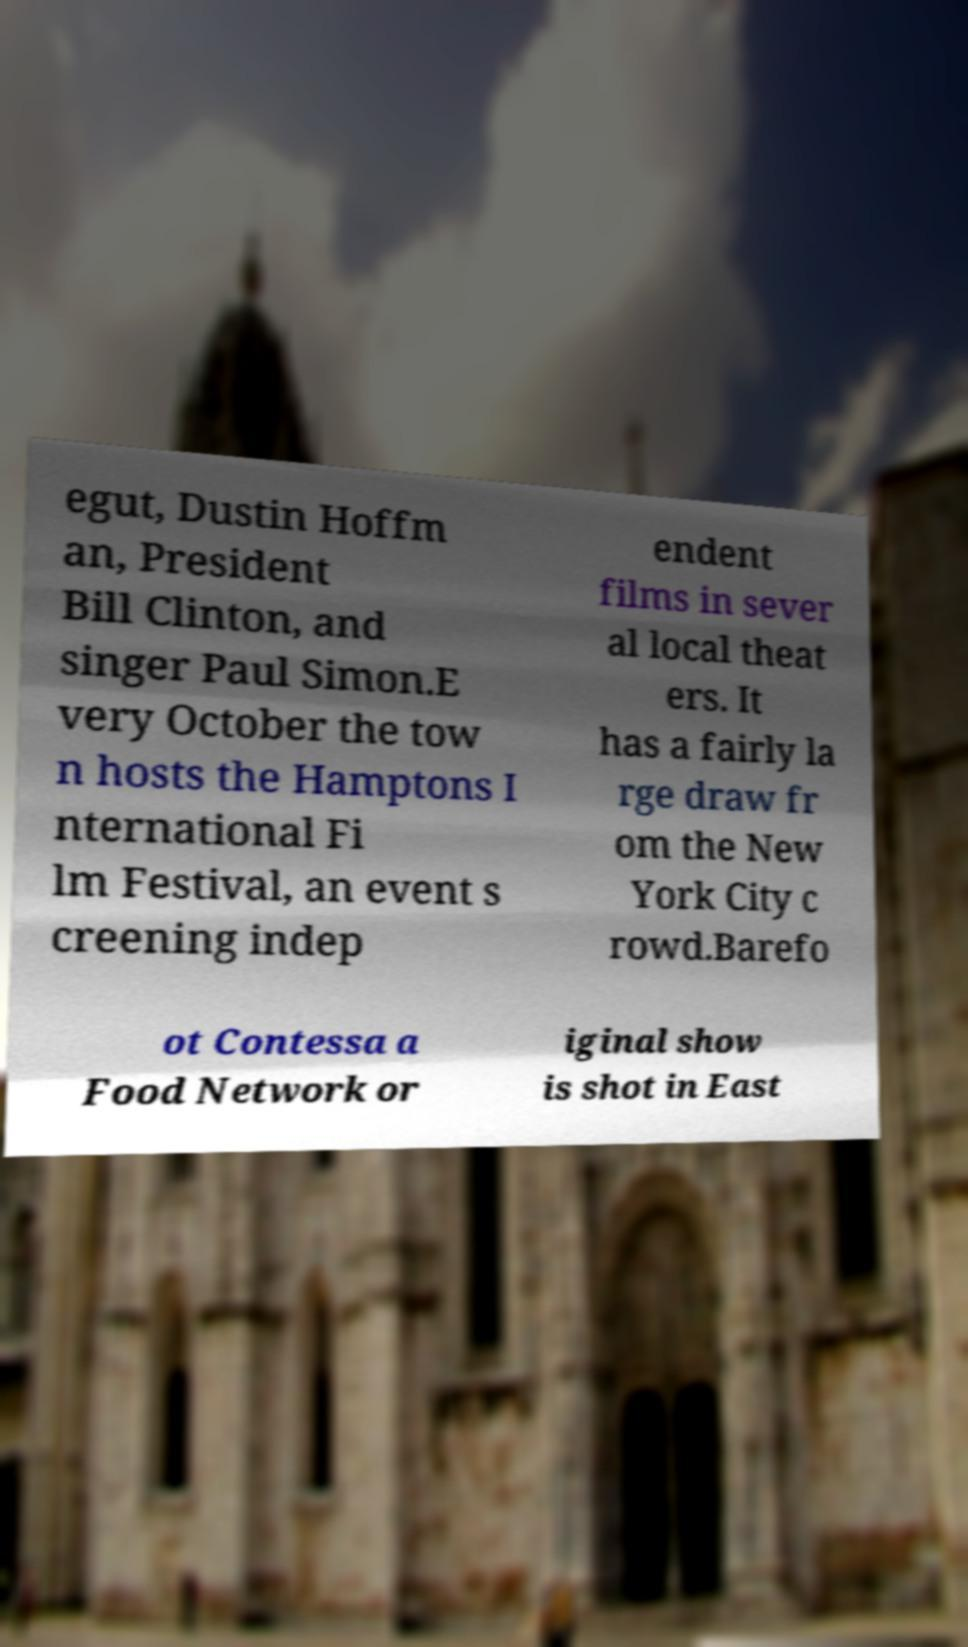What messages or text are displayed in this image? I need them in a readable, typed format. egut, Dustin Hoffm an, President Bill Clinton, and singer Paul Simon.E very October the tow n hosts the Hamptons I nternational Fi lm Festival, an event s creening indep endent films in sever al local theat ers. It has a fairly la rge draw fr om the New York City c rowd.Barefo ot Contessa a Food Network or iginal show is shot in East 